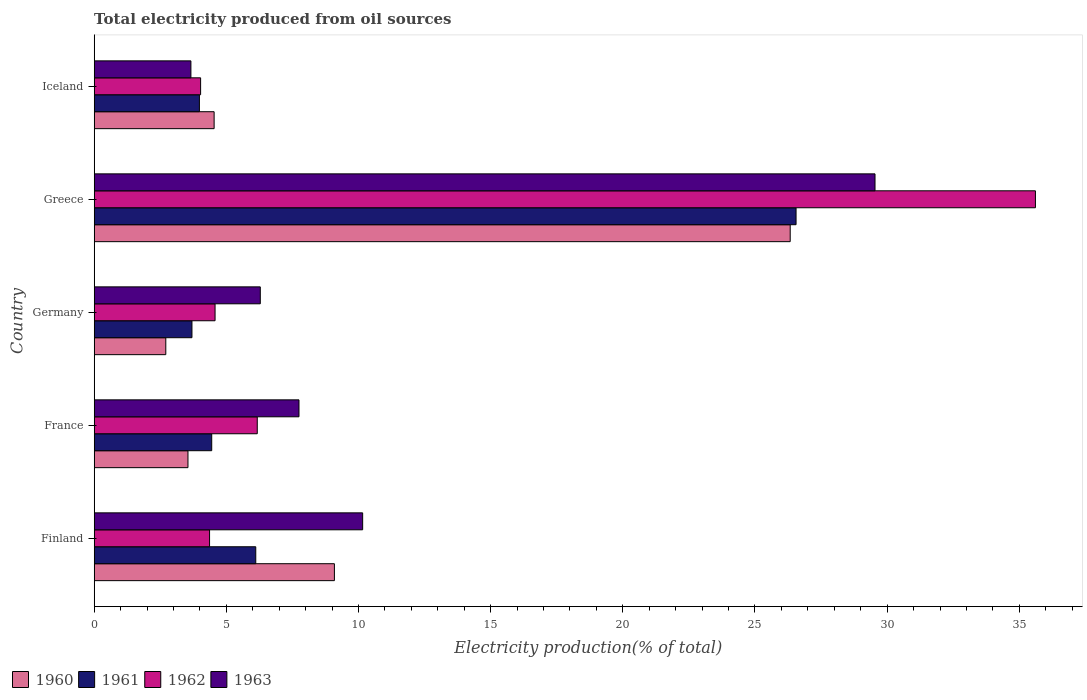How many groups of bars are there?
Keep it short and to the point. 5. How many bars are there on the 4th tick from the top?
Offer a very short reply. 4. In how many cases, is the number of bars for a given country not equal to the number of legend labels?
Provide a succinct answer. 0. What is the total electricity produced in 1962 in Iceland?
Provide a short and direct response. 4.03. Across all countries, what is the maximum total electricity produced in 1962?
Offer a terse response. 35.61. Across all countries, what is the minimum total electricity produced in 1962?
Offer a terse response. 4.03. What is the total total electricity produced in 1961 in the graph?
Give a very brief answer. 44.79. What is the difference between the total electricity produced in 1960 in Germany and that in Greece?
Your response must be concise. -23.62. What is the difference between the total electricity produced in 1961 in Greece and the total electricity produced in 1963 in Iceland?
Offer a terse response. 22.9. What is the average total electricity produced in 1961 per country?
Offer a very short reply. 8.96. What is the difference between the total electricity produced in 1963 and total electricity produced in 1962 in France?
Offer a terse response. 1.58. In how many countries, is the total electricity produced in 1962 greater than 17 %?
Give a very brief answer. 1. What is the ratio of the total electricity produced in 1960 in France to that in Iceland?
Provide a succinct answer. 0.78. Is the difference between the total electricity produced in 1963 in Germany and Greece greater than the difference between the total electricity produced in 1962 in Germany and Greece?
Give a very brief answer. Yes. What is the difference between the highest and the second highest total electricity produced in 1961?
Provide a short and direct response. 20.44. What is the difference between the highest and the lowest total electricity produced in 1962?
Give a very brief answer. 31.58. In how many countries, is the total electricity produced in 1960 greater than the average total electricity produced in 1960 taken over all countries?
Ensure brevity in your answer.  1. Is the sum of the total electricity produced in 1963 in France and Germany greater than the maximum total electricity produced in 1961 across all countries?
Your answer should be compact. No. Is it the case that in every country, the sum of the total electricity produced in 1960 and total electricity produced in 1963 is greater than the sum of total electricity produced in 1961 and total electricity produced in 1962?
Give a very brief answer. No. Is it the case that in every country, the sum of the total electricity produced in 1963 and total electricity produced in 1961 is greater than the total electricity produced in 1962?
Your answer should be compact. Yes. Are all the bars in the graph horizontal?
Provide a short and direct response. Yes. How many countries are there in the graph?
Your answer should be very brief. 5. Are the values on the major ticks of X-axis written in scientific E-notation?
Give a very brief answer. No. Does the graph contain any zero values?
Ensure brevity in your answer.  No. How many legend labels are there?
Offer a terse response. 4. How are the legend labels stacked?
Give a very brief answer. Horizontal. What is the title of the graph?
Give a very brief answer. Total electricity produced from oil sources. What is the label or title of the Y-axis?
Provide a succinct answer. Country. What is the Electricity production(% of total) in 1960 in Finland?
Offer a terse response. 9.09. What is the Electricity production(% of total) in 1961 in Finland?
Give a very brief answer. 6.11. What is the Electricity production(% of total) of 1962 in Finland?
Your response must be concise. 4.36. What is the Electricity production(% of total) of 1963 in Finland?
Your answer should be very brief. 10.16. What is the Electricity production(% of total) of 1960 in France?
Make the answer very short. 3.55. What is the Electricity production(% of total) of 1961 in France?
Provide a succinct answer. 4.45. What is the Electricity production(% of total) in 1962 in France?
Offer a terse response. 6.17. What is the Electricity production(% of total) in 1963 in France?
Provide a short and direct response. 7.75. What is the Electricity production(% of total) in 1960 in Germany?
Your response must be concise. 2.71. What is the Electricity production(% of total) in 1961 in Germany?
Provide a succinct answer. 3.7. What is the Electricity production(% of total) in 1962 in Germany?
Your answer should be compact. 4.57. What is the Electricity production(% of total) in 1963 in Germany?
Offer a very short reply. 6.28. What is the Electricity production(% of total) in 1960 in Greece?
Provide a short and direct response. 26.33. What is the Electricity production(% of total) of 1961 in Greece?
Your answer should be compact. 26.55. What is the Electricity production(% of total) in 1962 in Greece?
Your response must be concise. 35.61. What is the Electricity production(% of total) of 1963 in Greece?
Give a very brief answer. 29.54. What is the Electricity production(% of total) in 1960 in Iceland?
Provide a short and direct response. 4.54. What is the Electricity production(% of total) in 1961 in Iceland?
Your answer should be very brief. 3.98. What is the Electricity production(% of total) of 1962 in Iceland?
Give a very brief answer. 4.03. What is the Electricity production(% of total) of 1963 in Iceland?
Keep it short and to the point. 3.66. Across all countries, what is the maximum Electricity production(% of total) in 1960?
Provide a succinct answer. 26.33. Across all countries, what is the maximum Electricity production(% of total) of 1961?
Provide a succinct answer. 26.55. Across all countries, what is the maximum Electricity production(% of total) in 1962?
Offer a very short reply. 35.61. Across all countries, what is the maximum Electricity production(% of total) in 1963?
Offer a terse response. 29.54. Across all countries, what is the minimum Electricity production(% of total) of 1960?
Your response must be concise. 2.71. Across all countries, what is the minimum Electricity production(% of total) in 1961?
Your response must be concise. 3.7. Across all countries, what is the minimum Electricity production(% of total) in 1962?
Provide a short and direct response. 4.03. Across all countries, what is the minimum Electricity production(% of total) in 1963?
Your response must be concise. 3.66. What is the total Electricity production(% of total) in 1960 in the graph?
Your answer should be very brief. 46.21. What is the total Electricity production(% of total) of 1961 in the graph?
Offer a terse response. 44.79. What is the total Electricity production(% of total) of 1962 in the graph?
Your answer should be very brief. 54.74. What is the total Electricity production(% of total) of 1963 in the graph?
Your answer should be very brief. 57.39. What is the difference between the Electricity production(% of total) in 1960 in Finland and that in France?
Offer a terse response. 5.54. What is the difference between the Electricity production(% of total) in 1961 in Finland and that in France?
Keep it short and to the point. 1.67. What is the difference between the Electricity production(% of total) of 1962 in Finland and that in France?
Give a very brief answer. -1.8. What is the difference between the Electricity production(% of total) in 1963 in Finland and that in France?
Keep it short and to the point. 2.41. What is the difference between the Electricity production(% of total) of 1960 in Finland and that in Germany?
Your answer should be compact. 6.38. What is the difference between the Electricity production(% of total) of 1961 in Finland and that in Germany?
Provide a short and direct response. 2.41. What is the difference between the Electricity production(% of total) of 1962 in Finland and that in Germany?
Make the answer very short. -0.21. What is the difference between the Electricity production(% of total) in 1963 in Finland and that in Germany?
Give a very brief answer. 3.87. What is the difference between the Electricity production(% of total) in 1960 in Finland and that in Greece?
Keep it short and to the point. -17.24. What is the difference between the Electricity production(% of total) in 1961 in Finland and that in Greece?
Your response must be concise. -20.44. What is the difference between the Electricity production(% of total) of 1962 in Finland and that in Greece?
Provide a succinct answer. -31.25. What is the difference between the Electricity production(% of total) of 1963 in Finland and that in Greece?
Offer a terse response. -19.38. What is the difference between the Electricity production(% of total) of 1960 in Finland and that in Iceland?
Offer a very short reply. 4.55. What is the difference between the Electricity production(% of total) of 1961 in Finland and that in Iceland?
Your answer should be very brief. 2.13. What is the difference between the Electricity production(% of total) in 1962 in Finland and that in Iceland?
Make the answer very short. 0.34. What is the difference between the Electricity production(% of total) of 1963 in Finland and that in Iceland?
Your response must be concise. 6.5. What is the difference between the Electricity production(% of total) in 1960 in France and that in Germany?
Your answer should be compact. 0.84. What is the difference between the Electricity production(% of total) in 1961 in France and that in Germany?
Provide a succinct answer. 0.75. What is the difference between the Electricity production(% of total) in 1962 in France and that in Germany?
Provide a succinct answer. 1.6. What is the difference between the Electricity production(% of total) of 1963 in France and that in Germany?
Offer a very short reply. 1.46. What is the difference between the Electricity production(% of total) in 1960 in France and that in Greece?
Offer a terse response. -22.78. What is the difference between the Electricity production(% of total) in 1961 in France and that in Greece?
Provide a short and direct response. -22.11. What is the difference between the Electricity production(% of total) in 1962 in France and that in Greece?
Keep it short and to the point. -29.44. What is the difference between the Electricity production(% of total) of 1963 in France and that in Greece?
Ensure brevity in your answer.  -21.79. What is the difference between the Electricity production(% of total) of 1960 in France and that in Iceland?
Your response must be concise. -0.99. What is the difference between the Electricity production(% of total) in 1961 in France and that in Iceland?
Provide a short and direct response. 0.47. What is the difference between the Electricity production(% of total) of 1962 in France and that in Iceland?
Your response must be concise. 2.14. What is the difference between the Electricity production(% of total) in 1963 in France and that in Iceland?
Give a very brief answer. 4.09. What is the difference between the Electricity production(% of total) of 1960 in Germany and that in Greece?
Ensure brevity in your answer.  -23.62. What is the difference between the Electricity production(% of total) of 1961 in Germany and that in Greece?
Provide a short and direct response. -22.86. What is the difference between the Electricity production(% of total) in 1962 in Germany and that in Greece?
Keep it short and to the point. -31.04. What is the difference between the Electricity production(% of total) of 1963 in Germany and that in Greece?
Provide a succinct answer. -23.26. What is the difference between the Electricity production(% of total) of 1960 in Germany and that in Iceland?
Your answer should be compact. -1.83. What is the difference between the Electricity production(% of total) of 1961 in Germany and that in Iceland?
Offer a terse response. -0.28. What is the difference between the Electricity production(% of total) in 1962 in Germany and that in Iceland?
Offer a terse response. 0.55. What is the difference between the Electricity production(% of total) of 1963 in Germany and that in Iceland?
Give a very brief answer. 2.63. What is the difference between the Electricity production(% of total) in 1960 in Greece and that in Iceland?
Provide a succinct answer. 21.79. What is the difference between the Electricity production(% of total) of 1961 in Greece and that in Iceland?
Provide a short and direct response. 22.57. What is the difference between the Electricity production(% of total) of 1962 in Greece and that in Iceland?
Make the answer very short. 31.58. What is the difference between the Electricity production(% of total) of 1963 in Greece and that in Iceland?
Your answer should be compact. 25.88. What is the difference between the Electricity production(% of total) of 1960 in Finland and the Electricity production(% of total) of 1961 in France?
Your answer should be very brief. 4.64. What is the difference between the Electricity production(% of total) in 1960 in Finland and the Electricity production(% of total) in 1962 in France?
Offer a terse response. 2.92. What is the difference between the Electricity production(% of total) in 1960 in Finland and the Electricity production(% of total) in 1963 in France?
Provide a short and direct response. 1.34. What is the difference between the Electricity production(% of total) of 1961 in Finland and the Electricity production(% of total) of 1962 in France?
Provide a short and direct response. -0.06. What is the difference between the Electricity production(% of total) of 1961 in Finland and the Electricity production(% of total) of 1963 in France?
Keep it short and to the point. -1.64. What is the difference between the Electricity production(% of total) in 1962 in Finland and the Electricity production(% of total) in 1963 in France?
Provide a succinct answer. -3.38. What is the difference between the Electricity production(% of total) in 1960 in Finland and the Electricity production(% of total) in 1961 in Germany?
Your answer should be compact. 5.39. What is the difference between the Electricity production(% of total) of 1960 in Finland and the Electricity production(% of total) of 1962 in Germany?
Ensure brevity in your answer.  4.51. What is the difference between the Electricity production(% of total) of 1960 in Finland and the Electricity production(% of total) of 1963 in Germany?
Make the answer very short. 2.8. What is the difference between the Electricity production(% of total) in 1961 in Finland and the Electricity production(% of total) in 1962 in Germany?
Your response must be concise. 1.54. What is the difference between the Electricity production(% of total) in 1961 in Finland and the Electricity production(% of total) in 1963 in Germany?
Give a very brief answer. -0.17. What is the difference between the Electricity production(% of total) in 1962 in Finland and the Electricity production(% of total) in 1963 in Germany?
Provide a short and direct response. -1.92. What is the difference between the Electricity production(% of total) of 1960 in Finland and the Electricity production(% of total) of 1961 in Greece?
Keep it short and to the point. -17.47. What is the difference between the Electricity production(% of total) of 1960 in Finland and the Electricity production(% of total) of 1962 in Greece?
Your answer should be very brief. -26.52. What is the difference between the Electricity production(% of total) of 1960 in Finland and the Electricity production(% of total) of 1963 in Greece?
Keep it short and to the point. -20.45. What is the difference between the Electricity production(% of total) in 1961 in Finland and the Electricity production(% of total) in 1962 in Greece?
Offer a terse response. -29.5. What is the difference between the Electricity production(% of total) in 1961 in Finland and the Electricity production(% of total) in 1963 in Greece?
Make the answer very short. -23.43. What is the difference between the Electricity production(% of total) of 1962 in Finland and the Electricity production(% of total) of 1963 in Greece?
Provide a short and direct response. -25.18. What is the difference between the Electricity production(% of total) in 1960 in Finland and the Electricity production(% of total) in 1961 in Iceland?
Offer a very short reply. 5.11. What is the difference between the Electricity production(% of total) in 1960 in Finland and the Electricity production(% of total) in 1962 in Iceland?
Keep it short and to the point. 5.06. What is the difference between the Electricity production(% of total) of 1960 in Finland and the Electricity production(% of total) of 1963 in Iceland?
Offer a very short reply. 5.43. What is the difference between the Electricity production(% of total) in 1961 in Finland and the Electricity production(% of total) in 1962 in Iceland?
Keep it short and to the point. 2.09. What is the difference between the Electricity production(% of total) of 1961 in Finland and the Electricity production(% of total) of 1963 in Iceland?
Make the answer very short. 2.45. What is the difference between the Electricity production(% of total) of 1962 in Finland and the Electricity production(% of total) of 1963 in Iceland?
Offer a terse response. 0.71. What is the difference between the Electricity production(% of total) of 1960 in France and the Electricity production(% of total) of 1961 in Germany?
Provide a succinct answer. -0.15. What is the difference between the Electricity production(% of total) of 1960 in France and the Electricity production(% of total) of 1962 in Germany?
Your answer should be very brief. -1.02. What is the difference between the Electricity production(% of total) of 1960 in France and the Electricity production(% of total) of 1963 in Germany?
Your answer should be very brief. -2.74. What is the difference between the Electricity production(% of total) of 1961 in France and the Electricity production(% of total) of 1962 in Germany?
Your answer should be compact. -0.13. What is the difference between the Electricity production(% of total) in 1961 in France and the Electricity production(% of total) in 1963 in Germany?
Keep it short and to the point. -1.84. What is the difference between the Electricity production(% of total) of 1962 in France and the Electricity production(% of total) of 1963 in Germany?
Offer a very short reply. -0.11. What is the difference between the Electricity production(% of total) in 1960 in France and the Electricity production(% of total) in 1961 in Greece?
Provide a succinct answer. -23.01. What is the difference between the Electricity production(% of total) of 1960 in France and the Electricity production(% of total) of 1962 in Greece?
Offer a very short reply. -32.06. What is the difference between the Electricity production(% of total) in 1960 in France and the Electricity production(% of total) in 1963 in Greece?
Offer a very short reply. -25.99. What is the difference between the Electricity production(% of total) in 1961 in France and the Electricity production(% of total) in 1962 in Greece?
Your answer should be compact. -31.16. What is the difference between the Electricity production(% of total) in 1961 in France and the Electricity production(% of total) in 1963 in Greece?
Provide a short and direct response. -25.09. What is the difference between the Electricity production(% of total) of 1962 in France and the Electricity production(% of total) of 1963 in Greece?
Offer a very short reply. -23.37. What is the difference between the Electricity production(% of total) in 1960 in France and the Electricity production(% of total) in 1961 in Iceland?
Give a very brief answer. -0.43. What is the difference between the Electricity production(% of total) of 1960 in France and the Electricity production(% of total) of 1962 in Iceland?
Keep it short and to the point. -0.48. What is the difference between the Electricity production(% of total) in 1960 in France and the Electricity production(% of total) in 1963 in Iceland?
Your answer should be very brief. -0.11. What is the difference between the Electricity production(% of total) in 1961 in France and the Electricity production(% of total) in 1962 in Iceland?
Offer a terse response. 0.42. What is the difference between the Electricity production(% of total) of 1961 in France and the Electricity production(% of total) of 1963 in Iceland?
Give a very brief answer. 0.79. What is the difference between the Electricity production(% of total) in 1962 in France and the Electricity production(% of total) in 1963 in Iceland?
Your answer should be very brief. 2.51. What is the difference between the Electricity production(% of total) in 1960 in Germany and the Electricity production(% of total) in 1961 in Greece?
Provide a short and direct response. -23.85. What is the difference between the Electricity production(% of total) of 1960 in Germany and the Electricity production(% of total) of 1962 in Greece?
Ensure brevity in your answer.  -32.9. What is the difference between the Electricity production(% of total) in 1960 in Germany and the Electricity production(% of total) in 1963 in Greece?
Offer a very short reply. -26.83. What is the difference between the Electricity production(% of total) in 1961 in Germany and the Electricity production(% of total) in 1962 in Greece?
Provide a short and direct response. -31.91. What is the difference between the Electricity production(% of total) of 1961 in Germany and the Electricity production(% of total) of 1963 in Greece?
Your answer should be very brief. -25.84. What is the difference between the Electricity production(% of total) in 1962 in Germany and the Electricity production(% of total) in 1963 in Greece?
Make the answer very short. -24.97. What is the difference between the Electricity production(% of total) in 1960 in Germany and the Electricity production(% of total) in 1961 in Iceland?
Ensure brevity in your answer.  -1.27. What is the difference between the Electricity production(% of total) in 1960 in Germany and the Electricity production(% of total) in 1962 in Iceland?
Ensure brevity in your answer.  -1.32. What is the difference between the Electricity production(% of total) in 1960 in Germany and the Electricity production(% of total) in 1963 in Iceland?
Give a very brief answer. -0.95. What is the difference between the Electricity production(% of total) of 1961 in Germany and the Electricity production(% of total) of 1962 in Iceland?
Your answer should be very brief. -0.33. What is the difference between the Electricity production(% of total) of 1961 in Germany and the Electricity production(% of total) of 1963 in Iceland?
Keep it short and to the point. 0.04. What is the difference between the Electricity production(% of total) of 1962 in Germany and the Electricity production(% of total) of 1963 in Iceland?
Keep it short and to the point. 0.91. What is the difference between the Electricity production(% of total) in 1960 in Greece and the Electricity production(% of total) in 1961 in Iceland?
Provide a succinct answer. 22.35. What is the difference between the Electricity production(% of total) of 1960 in Greece and the Electricity production(% of total) of 1962 in Iceland?
Your answer should be compact. 22.31. What is the difference between the Electricity production(% of total) in 1960 in Greece and the Electricity production(% of total) in 1963 in Iceland?
Offer a terse response. 22.67. What is the difference between the Electricity production(% of total) of 1961 in Greece and the Electricity production(% of total) of 1962 in Iceland?
Your response must be concise. 22.53. What is the difference between the Electricity production(% of total) in 1961 in Greece and the Electricity production(% of total) in 1963 in Iceland?
Give a very brief answer. 22.9. What is the difference between the Electricity production(% of total) in 1962 in Greece and the Electricity production(% of total) in 1963 in Iceland?
Your answer should be compact. 31.95. What is the average Electricity production(% of total) in 1960 per country?
Your answer should be compact. 9.24. What is the average Electricity production(% of total) in 1961 per country?
Ensure brevity in your answer.  8.96. What is the average Electricity production(% of total) in 1962 per country?
Make the answer very short. 10.95. What is the average Electricity production(% of total) of 1963 per country?
Offer a very short reply. 11.48. What is the difference between the Electricity production(% of total) of 1960 and Electricity production(% of total) of 1961 in Finland?
Offer a terse response. 2.98. What is the difference between the Electricity production(% of total) in 1960 and Electricity production(% of total) in 1962 in Finland?
Ensure brevity in your answer.  4.72. What is the difference between the Electricity production(% of total) in 1960 and Electricity production(% of total) in 1963 in Finland?
Make the answer very short. -1.07. What is the difference between the Electricity production(% of total) in 1961 and Electricity production(% of total) in 1962 in Finland?
Your response must be concise. 1.75. What is the difference between the Electricity production(% of total) in 1961 and Electricity production(% of total) in 1963 in Finland?
Offer a very short reply. -4.04. What is the difference between the Electricity production(% of total) in 1962 and Electricity production(% of total) in 1963 in Finland?
Your answer should be very brief. -5.79. What is the difference between the Electricity production(% of total) of 1960 and Electricity production(% of total) of 1961 in France?
Your answer should be compact. -0.9. What is the difference between the Electricity production(% of total) of 1960 and Electricity production(% of total) of 1962 in France?
Ensure brevity in your answer.  -2.62. What is the difference between the Electricity production(% of total) in 1960 and Electricity production(% of total) in 1963 in France?
Your answer should be very brief. -4.2. What is the difference between the Electricity production(% of total) in 1961 and Electricity production(% of total) in 1962 in France?
Give a very brief answer. -1.72. What is the difference between the Electricity production(% of total) in 1961 and Electricity production(% of total) in 1963 in France?
Your answer should be very brief. -3.3. What is the difference between the Electricity production(% of total) of 1962 and Electricity production(% of total) of 1963 in France?
Your answer should be compact. -1.58. What is the difference between the Electricity production(% of total) of 1960 and Electricity production(% of total) of 1961 in Germany?
Offer a terse response. -0.99. What is the difference between the Electricity production(% of total) of 1960 and Electricity production(% of total) of 1962 in Germany?
Keep it short and to the point. -1.86. What is the difference between the Electricity production(% of total) of 1960 and Electricity production(% of total) of 1963 in Germany?
Keep it short and to the point. -3.58. What is the difference between the Electricity production(% of total) in 1961 and Electricity production(% of total) in 1962 in Germany?
Make the answer very short. -0.87. What is the difference between the Electricity production(% of total) in 1961 and Electricity production(% of total) in 1963 in Germany?
Provide a succinct answer. -2.59. What is the difference between the Electricity production(% of total) in 1962 and Electricity production(% of total) in 1963 in Germany?
Provide a succinct answer. -1.71. What is the difference between the Electricity production(% of total) in 1960 and Electricity production(% of total) in 1961 in Greece?
Give a very brief answer. -0.22. What is the difference between the Electricity production(% of total) in 1960 and Electricity production(% of total) in 1962 in Greece?
Ensure brevity in your answer.  -9.28. What is the difference between the Electricity production(% of total) in 1960 and Electricity production(% of total) in 1963 in Greece?
Your response must be concise. -3.21. What is the difference between the Electricity production(% of total) in 1961 and Electricity production(% of total) in 1962 in Greece?
Ensure brevity in your answer.  -9.06. What is the difference between the Electricity production(% of total) in 1961 and Electricity production(% of total) in 1963 in Greece?
Make the answer very short. -2.99. What is the difference between the Electricity production(% of total) in 1962 and Electricity production(% of total) in 1963 in Greece?
Your answer should be compact. 6.07. What is the difference between the Electricity production(% of total) in 1960 and Electricity production(% of total) in 1961 in Iceland?
Provide a short and direct response. 0.56. What is the difference between the Electricity production(% of total) in 1960 and Electricity production(% of total) in 1962 in Iceland?
Offer a terse response. 0.51. What is the difference between the Electricity production(% of total) of 1960 and Electricity production(% of total) of 1963 in Iceland?
Your answer should be compact. 0.88. What is the difference between the Electricity production(% of total) in 1961 and Electricity production(% of total) in 1962 in Iceland?
Your answer should be compact. -0.05. What is the difference between the Electricity production(% of total) in 1961 and Electricity production(% of total) in 1963 in Iceland?
Offer a very short reply. 0.32. What is the difference between the Electricity production(% of total) in 1962 and Electricity production(% of total) in 1963 in Iceland?
Make the answer very short. 0.37. What is the ratio of the Electricity production(% of total) in 1960 in Finland to that in France?
Provide a succinct answer. 2.56. What is the ratio of the Electricity production(% of total) of 1961 in Finland to that in France?
Your response must be concise. 1.37. What is the ratio of the Electricity production(% of total) in 1962 in Finland to that in France?
Your response must be concise. 0.71. What is the ratio of the Electricity production(% of total) in 1963 in Finland to that in France?
Your answer should be very brief. 1.31. What is the ratio of the Electricity production(% of total) in 1960 in Finland to that in Germany?
Your answer should be compact. 3.36. What is the ratio of the Electricity production(% of total) of 1961 in Finland to that in Germany?
Provide a succinct answer. 1.65. What is the ratio of the Electricity production(% of total) of 1962 in Finland to that in Germany?
Offer a terse response. 0.95. What is the ratio of the Electricity production(% of total) of 1963 in Finland to that in Germany?
Provide a succinct answer. 1.62. What is the ratio of the Electricity production(% of total) of 1960 in Finland to that in Greece?
Your answer should be compact. 0.35. What is the ratio of the Electricity production(% of total) of 1961 in Finland to that in Greece?
Ensure brevity in your answer.  0.23. What is the ratio of the Electricity production(% of total) in 1962 in Finland to that in Greece?
Your response must be concise. 0.12. What is the ratio of the Electricity production(% of total) in 1963 in Finland to that in Greece?
Offer a very short reply. 0.34. What is the ratio of the Electricity production(% of total) in 1960 in Finland to that in Iceland?
Your answer should be very brief. 2. What is the ratio of the Electricity production(% of total) in 1961 in Finland to that in Iceland?
Give a very brief answer. 1.54. What is the ratio of the Electricity production(% of total) of 1962 in Finland to that in Iceland?
Keep it short and to the point. 1.08. What is the ratio of the Electricity production(% of total) in 1963 in Finland to that in Iceland?
Offer a very short reply. 2.78. What is the ratio of the Electricity production(% of total) in 1960 in France to that in Germany?
Provide a succinct answer. 1.31. What is the ratio of the Electricity production(% of total) in 1961 in France to that in Germany?
Your response must be concise. 1.2. What is the ratio of the Electricity production(% of total) of 1962 in France to that in Germany?
Your answer should be very brief. 1.35. What is the ratio of the Electricity production(% of total) of 1963 in France to that in Germany?
Your answer should be compact. 1.23. What is the ratio of the Electricity production(% of total) in 1960 in France to that in Greece?
Your answer should be compact. 0.13. What is the ratio of the Electricity production(% of total) of 1961 in France to that in Greece?
Keep it short and to the point. 0.17. What is the ratio of the Electricity production(% of total) of 1962 in France to that in Greece?
Your answer should be compact. 0.17. What is the ratio of the Electricity production(% of total) of 1963 in France to that in Greece?
Your answer should be very brief. 0.26. What is the ratio of the Electricity production(% of total) in 1960 in France to that in Iceland?
Ensure brevity in your answer.  0.78. What is the ratio of the Electricity production(% of total) in 1961 in France to that in Iceland?
Your response must be concise. 1.12. What is the ratio of the Electricity production(% of total) in 1962 in France to that in Iceland?
Your response must be concise. 1.53. What is the ratio of the Electricity production(% of total) of 1963 in France to that in Iceland?
Keep it short and to the point. 2.12. What is the ratio of the Electricity production(% of total) in 1960 in Germany to that in Greece?
Make the answer very short. 0.1. What is the ratio of the Electricity production(% of total) in 1961 in Germany to that in Greece?
Offer a terse response. 0.14. What is the ratio of the Electricity production(% of total) in 1962 in Germany to that in Greece?
Your answer should be very brief. 0.13. What is the ratio of the Electricity production(% of total) in 1963 in Germany to that in Greece?
Make the answer very short. 0.21. What is the ratio of the Electricity production(% of total) in 1960 in Germany to that in Iceland?
Offer a very short reply. 0.6. What is the ratio of the Electricity production(% of total) in 1961 in Germany to that in Iceland?
Your response must be concise. 0.93. What is the ratio of the Electricity production(% of total) in 1962 in Germany to that in Iceland?
Provide a succinct answer. 1.14. What is the ratio of the Electricity production(% of total) of 1963 in Germany to that in Iceland?
Keep it short and to the point. 1.72. What is the ratio of the Electricity production(% of total) of 1960 in Greece to that in Iceland?
Your response must be concise. 5.8. What is the ratio of the Electricity production(% of total) of 1961 in Greece to that in Iceland?
Offer a terse response. 6.67. What is the ratio of the Electricity production(% of total) of 1962 in Greece to that in Iceland?
Give a very brief answer. 8.85. What is the ratio of the Electricity production(% of total) of 1963 in Greece to that in Iceland?
Give a very brief answer. 8.07. What is the difference between the highest and the second highest Electricity production(% of total) in 1960?
Make the answer very short. 17.24. What is the difference between the highest and the second highest Electricity production(% of total) in 1961?
Offer a very short reply. 20.44. What is the difference between the highest and the second highest Electricity production(% of total) of 1962?
Offer a very short reply. 29.44. What is the difference between the highest and the second highest Electricity production(% of total) of 1963?
Offer a very short reply. 19.38. What is the difference between the highest and the lowest Electricity production(% of total) in 1960?
Your response must be concise. 23.62. What is the difference between the highest and the lowest Electricity production(% of total) of 1961?
Give a very brief answer. 22.86. What is the difference between the highest and the lowest Electricity production(% of total) in 1962?
Offer a very short reply. 31.58. What is the difference between the highest and the lowest Electricity production(% of total) in 1963?
Give a very brief answer. 25.88. 